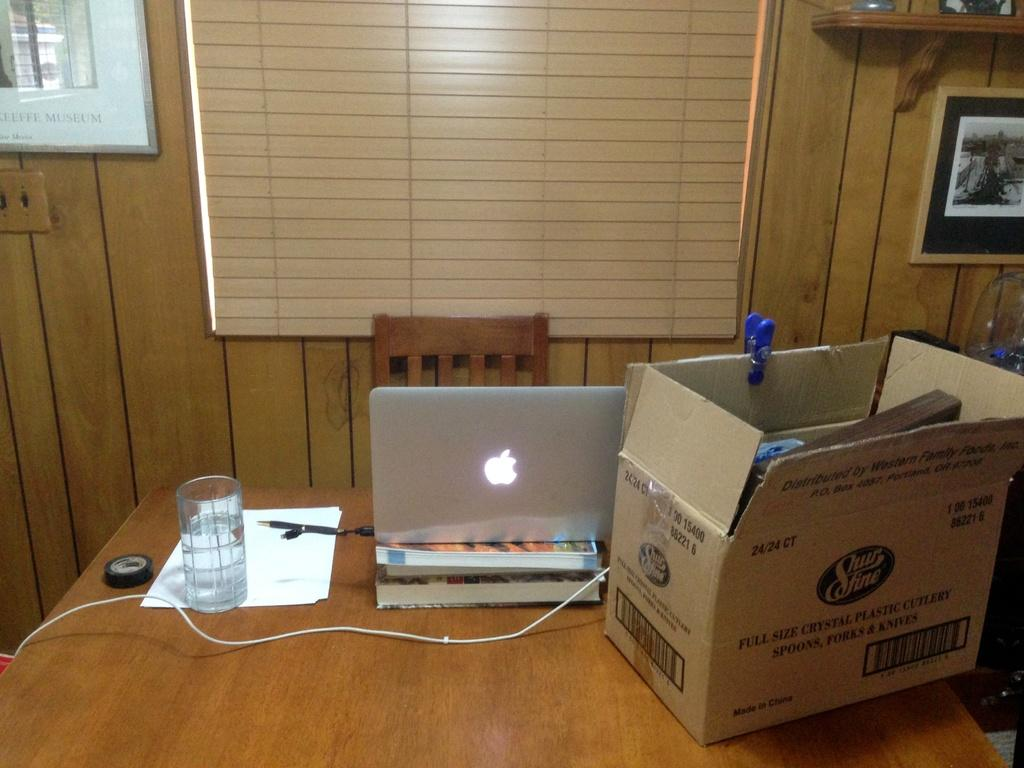What electronic device is on the table in the image? There is a laptop on the table. What type of container is on the table? There is a glass on the table. What writing instruments are on the table? There are pens on the table. What type of paper is on the table? There are papers on the table. What adhesive material is on the table? There is tape on the table. What type of storage container is on the table? There is a cardboard box on the table. What type of reading material is on the table? There are books on the table. What type of wire is on the table? There is a wire on the table. What type of furniture is in the background? There is a chair in the background. What type of window covering is in the background? There are window blinds in the background. What type of decorative item is on the wall in the background? There is a photo frame on the wall in the background. What type of food is on the table in the image? There is no food present on the table in the image. How many snakes can be seen slithering on the table in the image? There are no snakes present on the table in the image. 